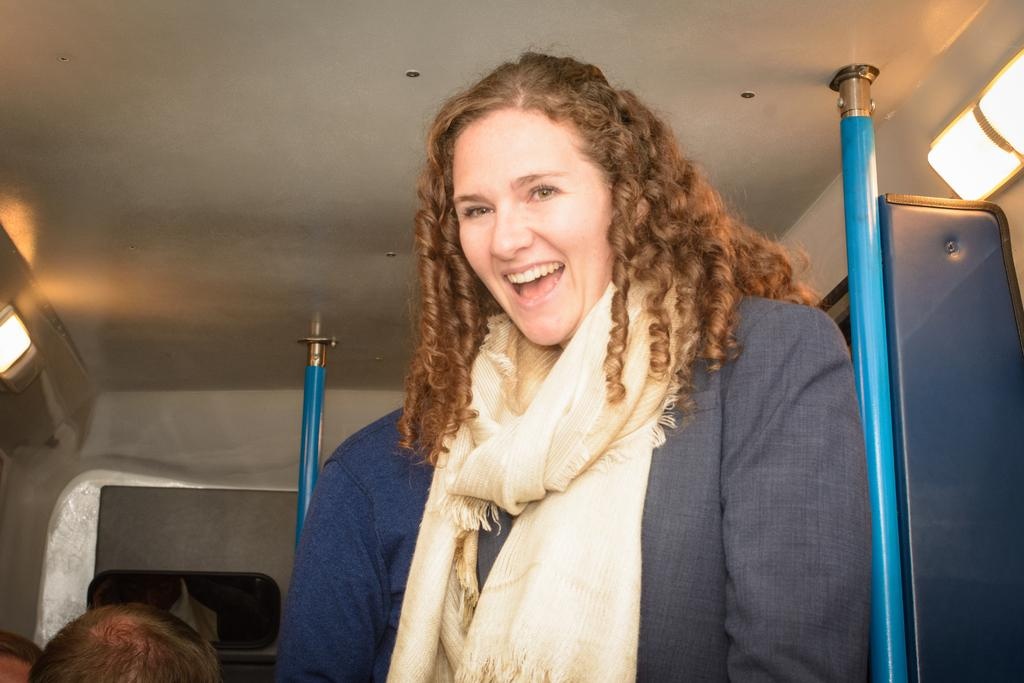Who is present in the image? There is a woman in the image. What is the woman's facial expression? The woman is smiling. What can be seen in the background of the image? There are rods and lights in the background of the image. What type of jeans is the crow wearing in the image? There is no crow or jeans present in the image. How does the woman's feeling of happiness affect the lighting in the image? The image does not provide information about the woman's feelings or how they might affect the lighting. 